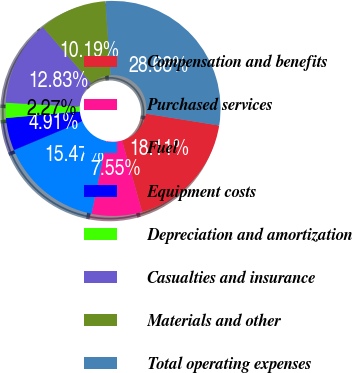Convert chart to OTSL. <chart><loc_0><loc_0><loc_500><loc_500><pie_chart><fcel>Compensation and benefits<fcel>Purchased services<fcel>Fuel<fcel>Equipment costs<fcel>Depreciation and amortization<fcel>Casualties and insurance<fcel>Materials and other<fcel>Total operating expenses<nl><fcel>18.11%<fcel>7.55%<fcel>15.47%<fcel>4.91%<fcel>2.27%<fcel>12.83%<fcel>10.19%<fcel>28.68%<nl></chart> 